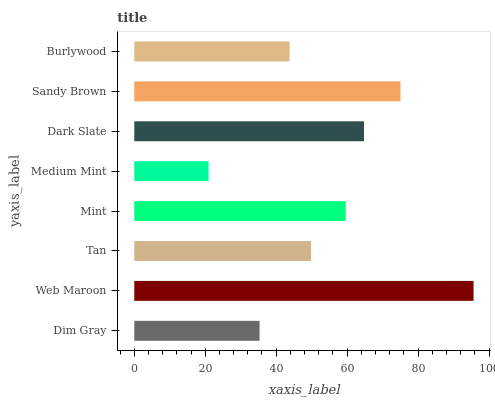Is Medium Mint the minimum?
Answer yes or no. Yes. Is Web Maroon the maximum?
Answer yes or no. Yes. Is Tan the minimum?
Answer yes or no. No. Is Tan the maximum?
Answer yes or no. No. Is Web Maroon greater than Tan?
Answer yes or no. Yes. Is Tan less than Web Maroon?
Answer yes or no. Yes. Is Tan greater than Web Maroon?
Answer yes or no. No. Is Web Maroon less than Tan?
Answer yes or no. No. Is Mint the high median?
Answer yes or no. Yes. Is Tan the low median?
Answer yes or no. Yes. Is Dark Slate the high median?
Answer yes or no. No. Is Dark Slate the low median?
Answer yes or no. No. 